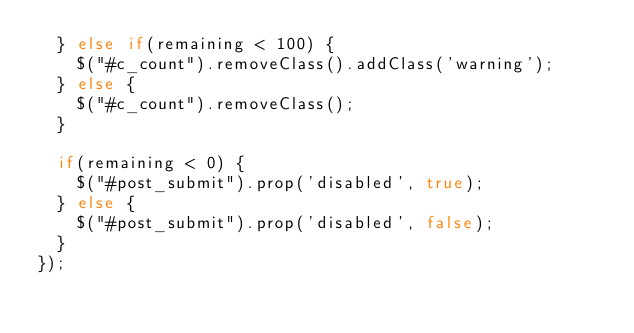<code> <loc_0><loc_0><loc_500><loc_500><_JavaScript_>  } else if(remaining < 100) {
    $("#c_count").removeClass().addClass('warning');
  } else {
    $("#c_count").removeClass();
  }
  
  if(remaining < 0) {
    $("#post_submit").prop('disabled', true);
  } else {
    $("#post_submit").prop('disabled', false);
  }
});</code> 